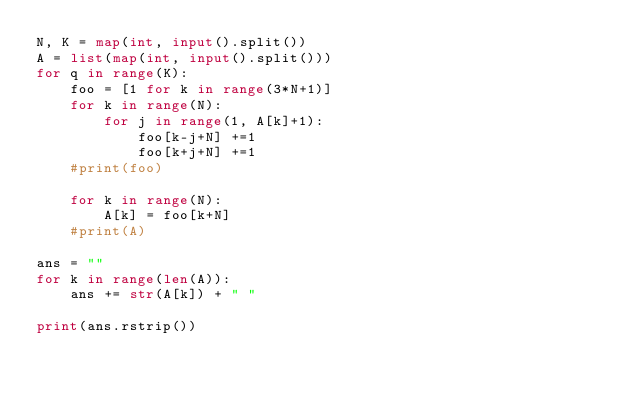Convert code to text. <code><loc_0><loc_0><loc_500><loc_500><_Python_>N, K = map(int, input().split())
A = list(map(int, input().split()))
for q in range(K):
    foo = [1 for k in range(3*N+1)]
    for k in range(N):
        for j in range(1, A[k]+1):
            foo[k-j+N] +=1
            foo[k+j+N] +=1
    #print(foo)

    for k in range(N):
        A[k] = foo[k+N]
    #print(A)

ans = ""
for k in range(len(A)):
    ans += str(A[k]) + " "

print(ans.rstrip())</code> 